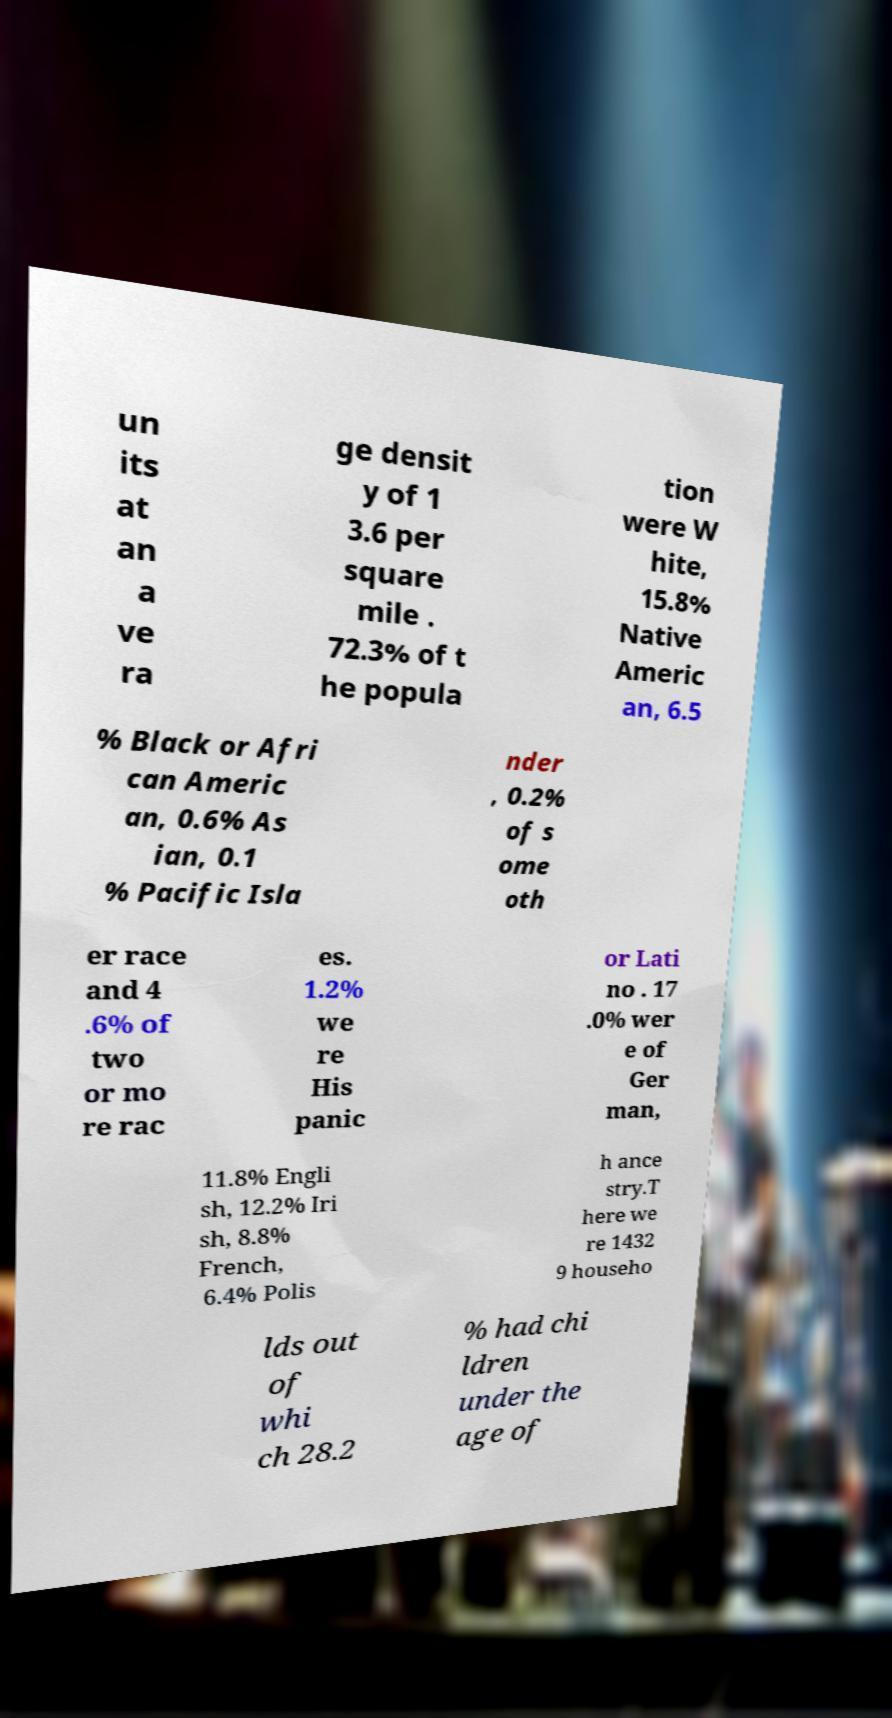Can you read and provide the text displayed in the image?This photo seems to have some interesting text. Can you extract and type it out for me? un its at an a ve ra ge densit y of 1 3.6 per square mile . 72.3% of t he popula tion were W hite, 15.8% Native Americ an, 6.5 % Black or Afri can Americ an, 0.6% As ian, 0.1 % Pacific Isla nder , 0.2% of s ome oth er race and 4 .6% of two or mo re rac es. 1.2% we re His panic or Lati no . 17 .0% wer e of Ger man, 11.8% Engli sh, 12.2% Iri sh, 8.8% French, 6.4% Polis h ance stry.T here we re 1432 9 househo lds out of whi ch 28.2 % had chi ldren under the age of 